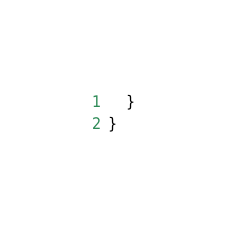Convert code to text. <code><loc_0><loc_0><loc_500><loc_500><_PHP_>    }
}
</code> 